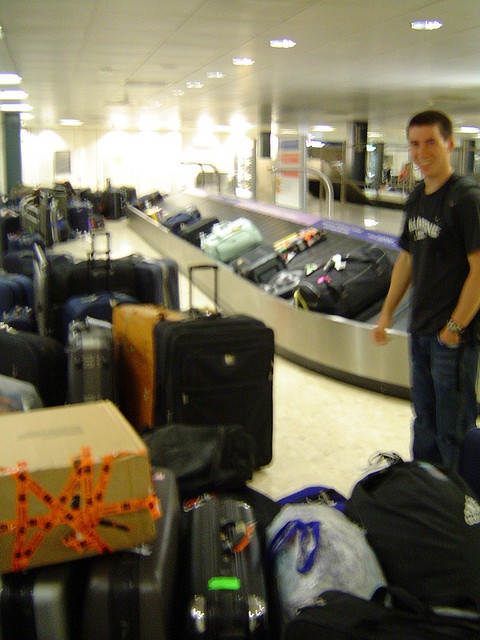Describe the objects in this image and their specific colors. I can see people in olive, black, and gray tones, suitcase in olive, black, gray, darkgray, and darkgreen tones, suitcase in olive, black, tan, khaki, and beige tones, backpack in olive, black, gray, and darkgray tones, and suitcase in olive, black, darkgreen, and gray tones in this image. 